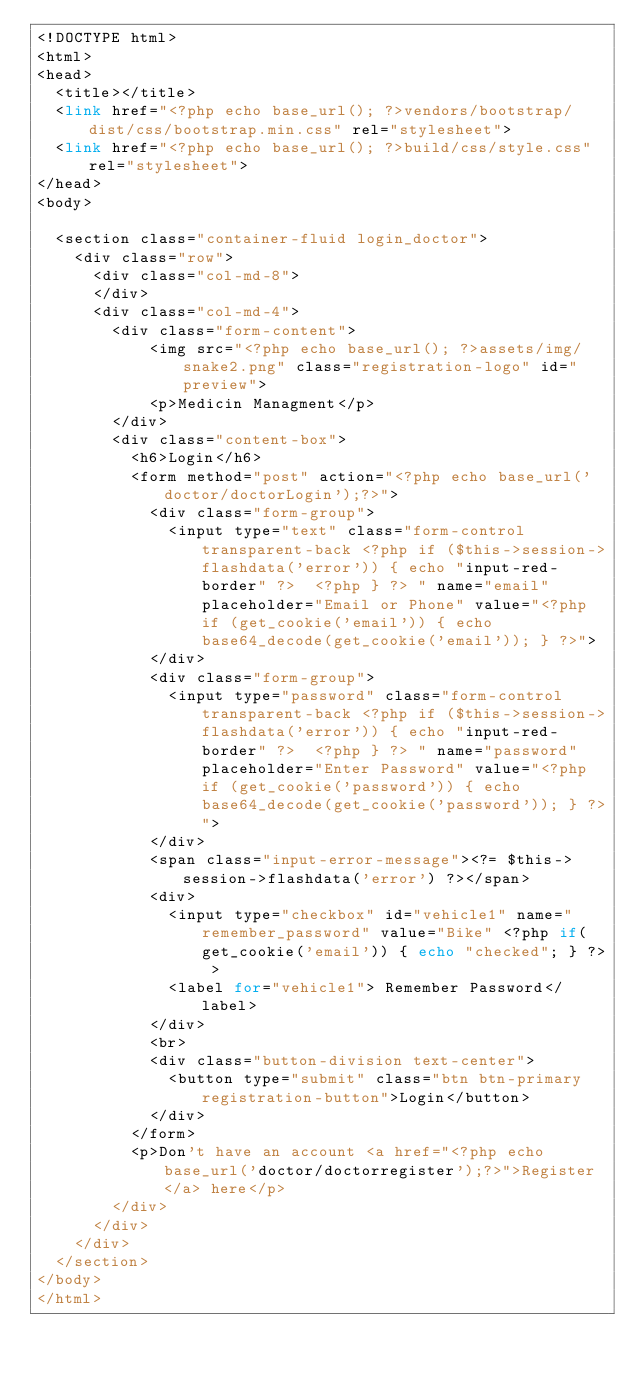Convert code to text. <code><loc_0><loc_0><loc_500><loc_500><_PHP_><!DOCTYPE html>
<html>
<head>
	<title></title>
	<link href="<?php echo base_url(); ?>vendors/bootstrap/dist/css/bootstrap.min.css" rel="stylesheet">
	<link href="<?php echo base_url(); ?>build/css/style.css" rel="stylesheet">
</head>
<body>

	<section class="container-fluid login_doctor">
	  <div class="row">
	    <div class="col-md-8">       
	    </div>
	    <div class="col-md-4">
	      <div class="form-content">
	          <img src="<?php echo base_url(); ?>assets/img/snake2.png" class="registration-logo" id="preview">       
	          <p>Medicin Managment</p>
	      </div>             
	      <div class="content-box">        
	        <h6>Login</h6>
	        <form method="post" action="<?php echo base_url('doctor/doctorLogin');?>">
	          <div class="form-group">
	            <input type="text" class="form-control transparent-back <?php if ($this->session->flashdata('error')) { echo "input-red-border" ?>  <?php } ?> " name="email" placeholder="Email or Phone" value="<?php if (get_cookie('email')) { echo base64_decode(get_cookie('email')); } ?>">
	          </div>        
	          <div class="form-group">
	            <input type="password" class="form-control transparent-back <?php if ($this->session->flashdata('error')) { echo "input-red-border" ?>  <?php } ?> " name="password" placeholder="Enter Password" value="<?php if (get_cookie('password')) { echo base64_decode(get_cookie('password')); } ?>">
	          </div>        
	          <span class="input-error-message"><?= $this->session->flashdata('error') ?></span>
	          <div>            
	            <input type="checkbox" id="vehicle1" name="remember_password" value="Bike" <?php if(get_cookie('email')) { echo "checked"; } ?> >
	            <label for="vehicle1"> Remember Password</label>
	          </div>
	          <br>
	          <div class="button-division text-center">          
	            <button type="submit" class="btn btn-primary registration-button">Login</button>
	          </div>
	        </form>
	        <p>Don't have an account <a href="<?php echo base_url('doctor/doctorregister');?>">Register</a> here</p>        
	      </div>      
	    </div>
	  </div>
	</section>
</body>
</html></code> 